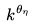Convert formula to latex. <formula><loc_0><loc_0><loc_500><loc_500>k ^ { \theta _ { \eta } }</formula> 